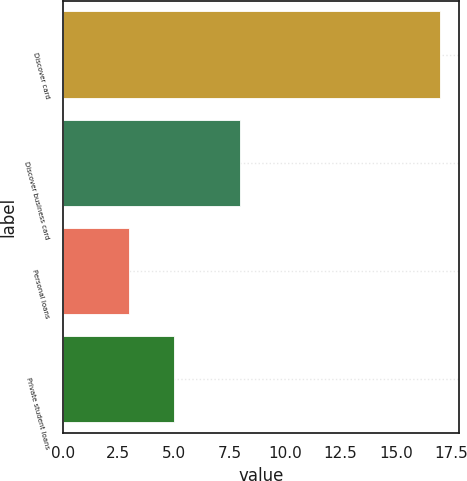Convert chart. <chart><loc_0><loc_0><loc_500><loc_500><bar_chart><fcel>Discover card<fcel>Discover business card<fcel>Personal loans<fcel>Private student loans<nl><fcel>17<fcel>8<fcel>3<fcel>5<nl></chart> 